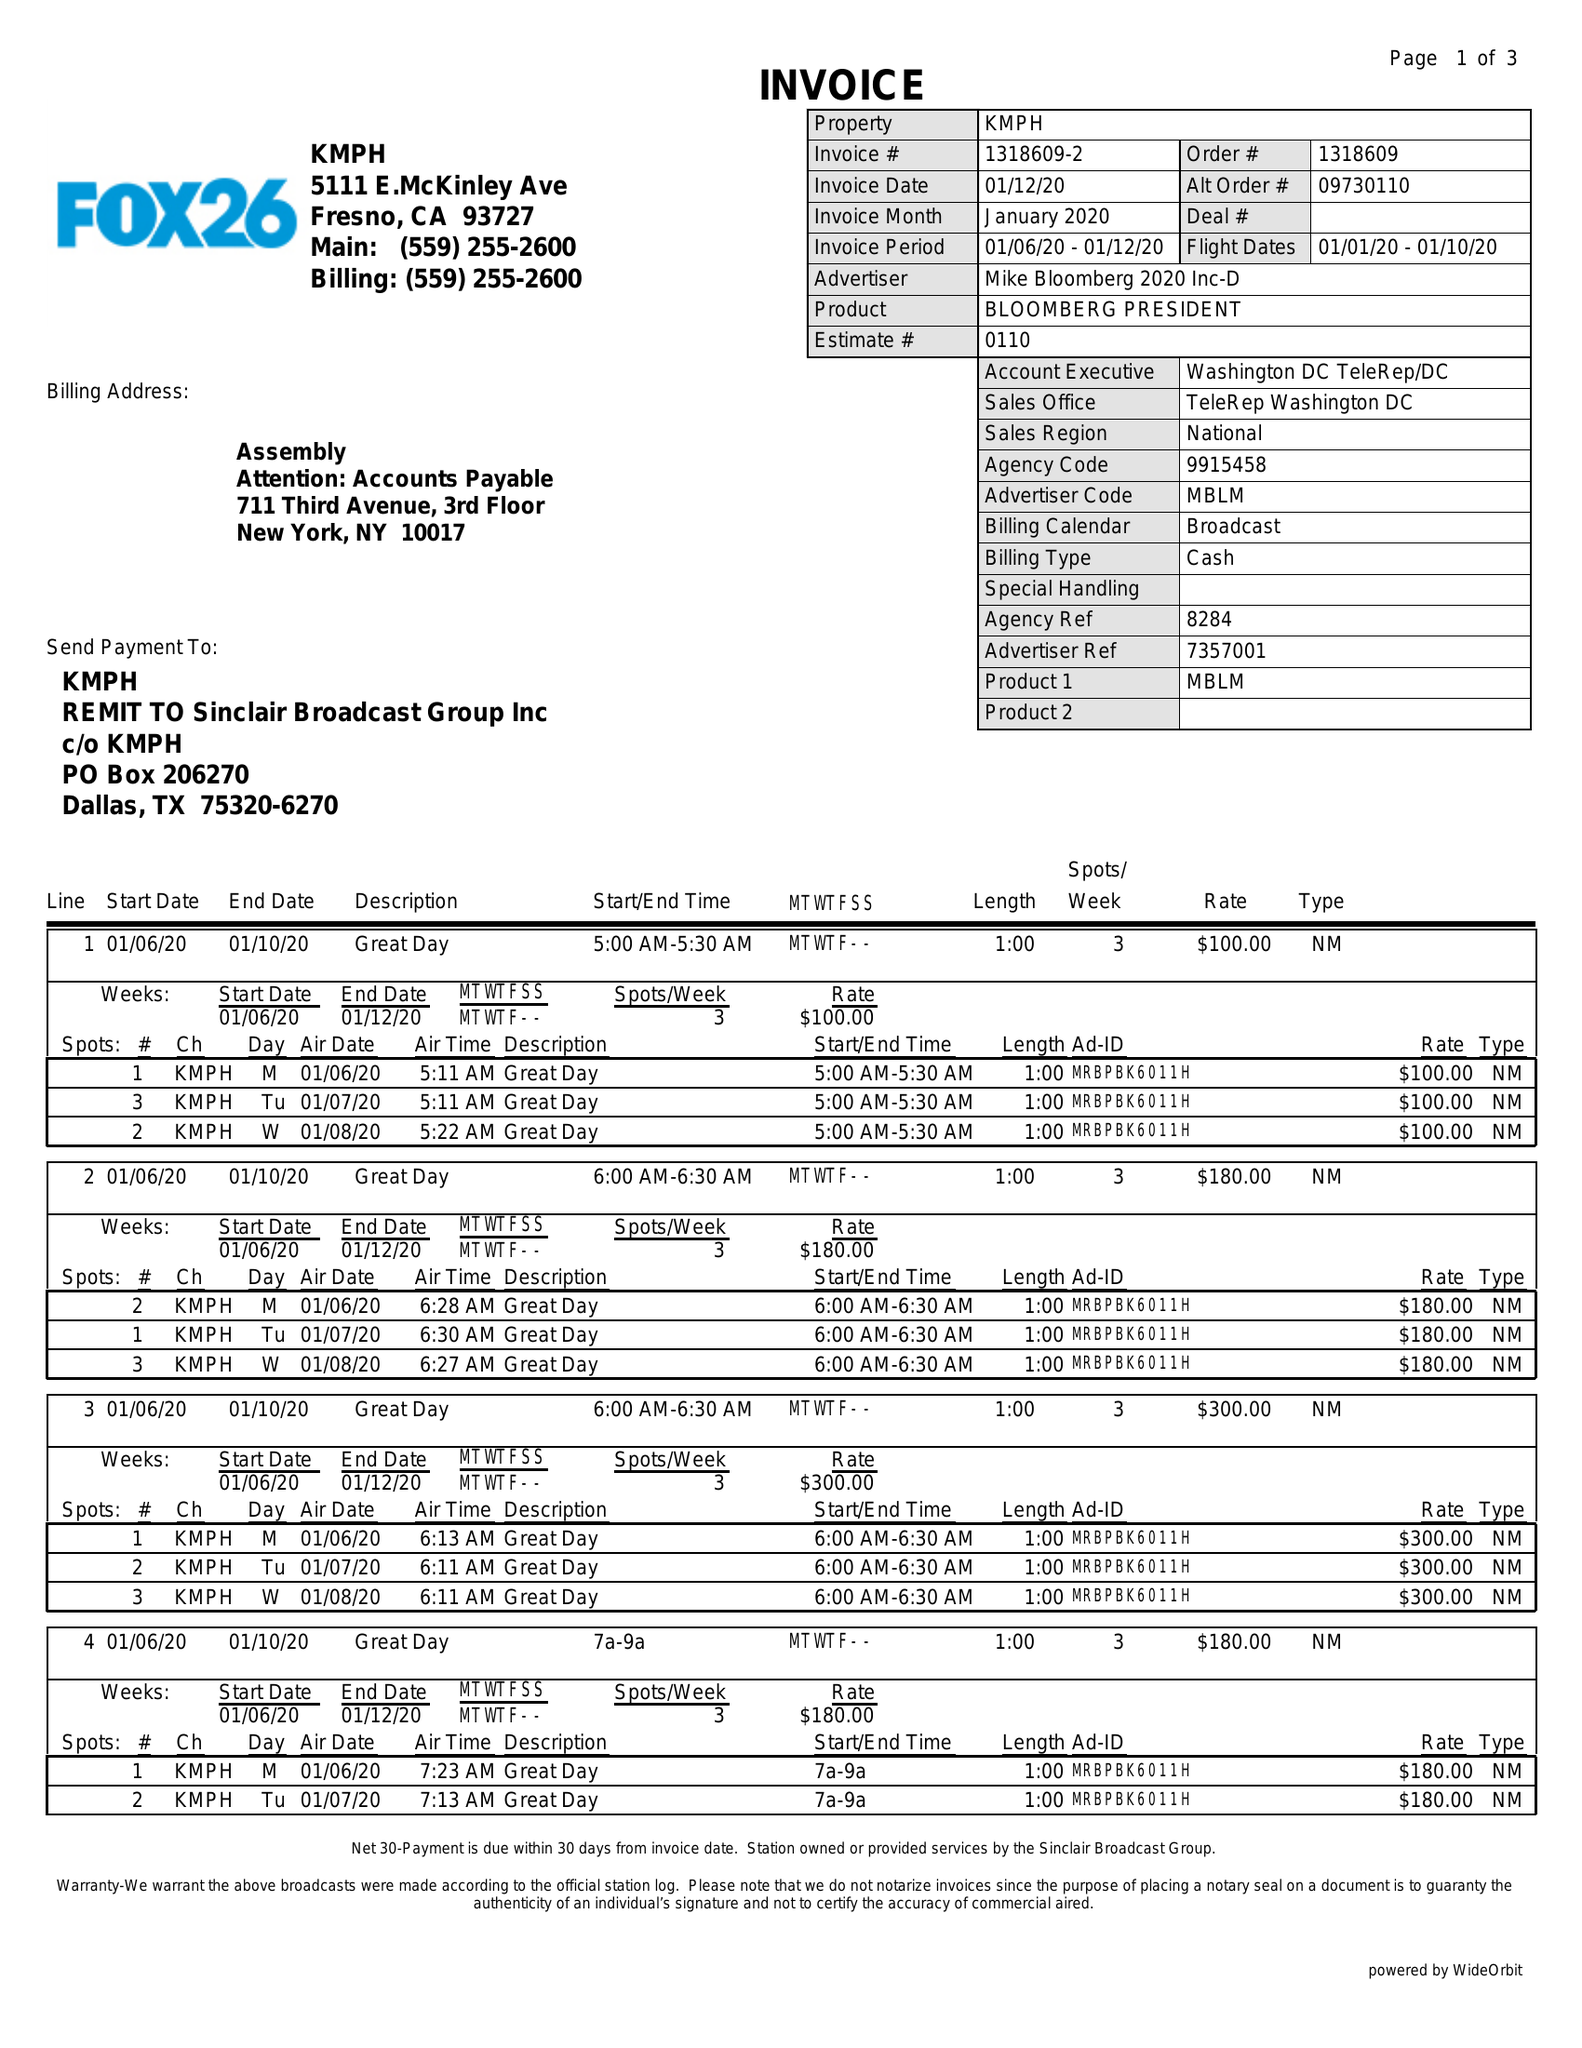What is the value for the flight_from?
Answer the question using a single word or phrase. 01/01/20 